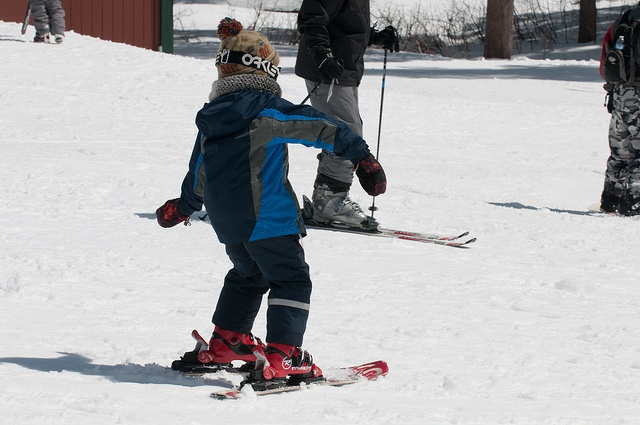Describe the objects in this image and their specific colors. I can see people in maroon, black, gray, darkblue, and blue tones, people in maroon, black, gray, lightgray, and purple tones, people in maroon, black, gray, darkgray, and purple tones, skis in maroon, lightgray, black, gray, and darkgray tones, and backpack in maroon, black, gray, and blue tones in this image. 